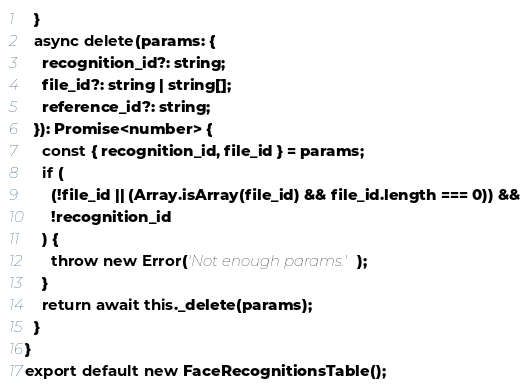<code> <loc_0><loc_0><loc_500><loc_500><_TypeScript_>  }
  async delete(params: {
    recognition_id?: string;
    file_id?: string | string[];
    reference_id?: string;
  }): Promise<number> {
    const { recognition_id, file_id } = params;
    if (
      (!file_id || (Array.isArray(file_id) && file_id.length === 0)) &&
      !recognition_id
    ) {
      throw new Error('Not enough params.');
    }
    return await this._delete(params);
  }
}
export default new FaceRecognitionsTable();
</code> 